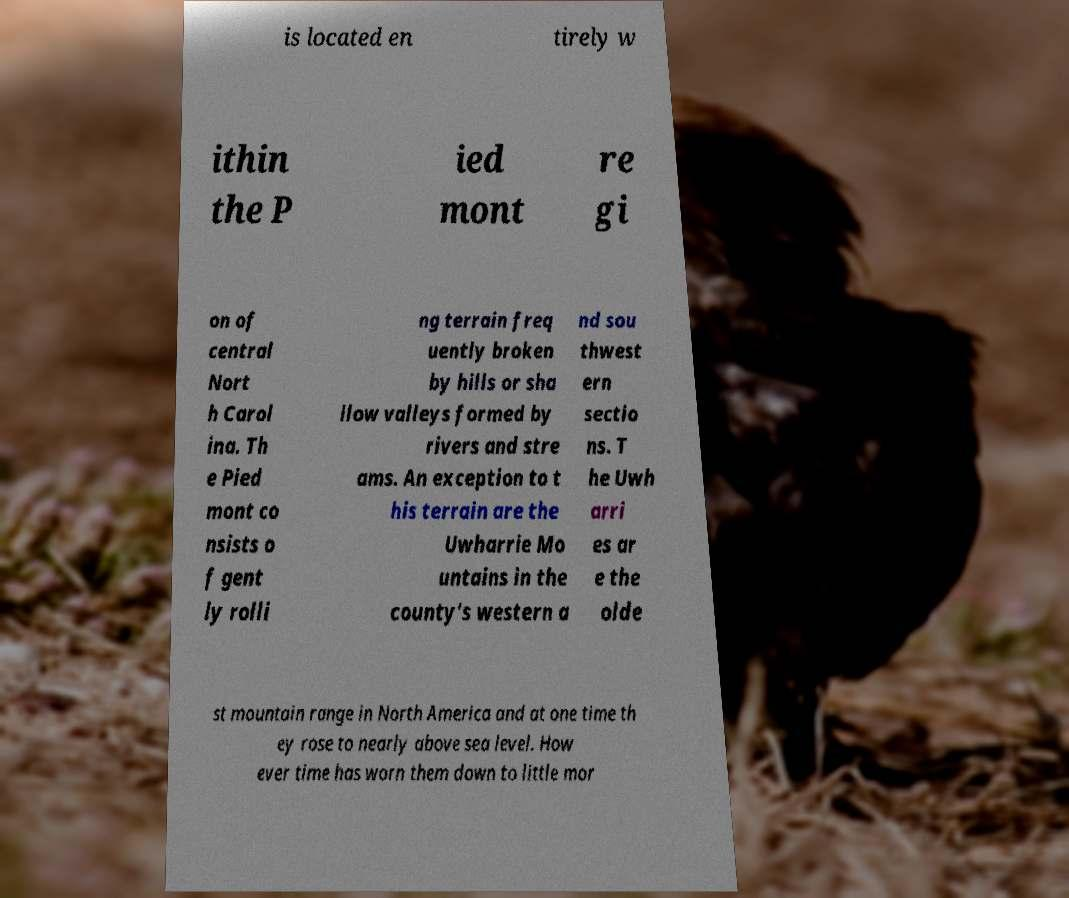Can you accurately transcribe the text from the provided image for me? is located en tirely w ithin the P ied mont re gi on of central Nort h Carol ina. Th e Pied mont co nsists o f gent ly rolli ng terrain freq uently broken by hills or sha llow valleys formed by rivers and stre ams. An exception to t his terrain are the Uwharrie Mo untains in the county's western a nd sou thwest ern sectio ns. T he Uwh arri es ar e the olde st mountain range in North America and at one time th ey rose to nearly above sea level. How ever time has worn them down to little mor 